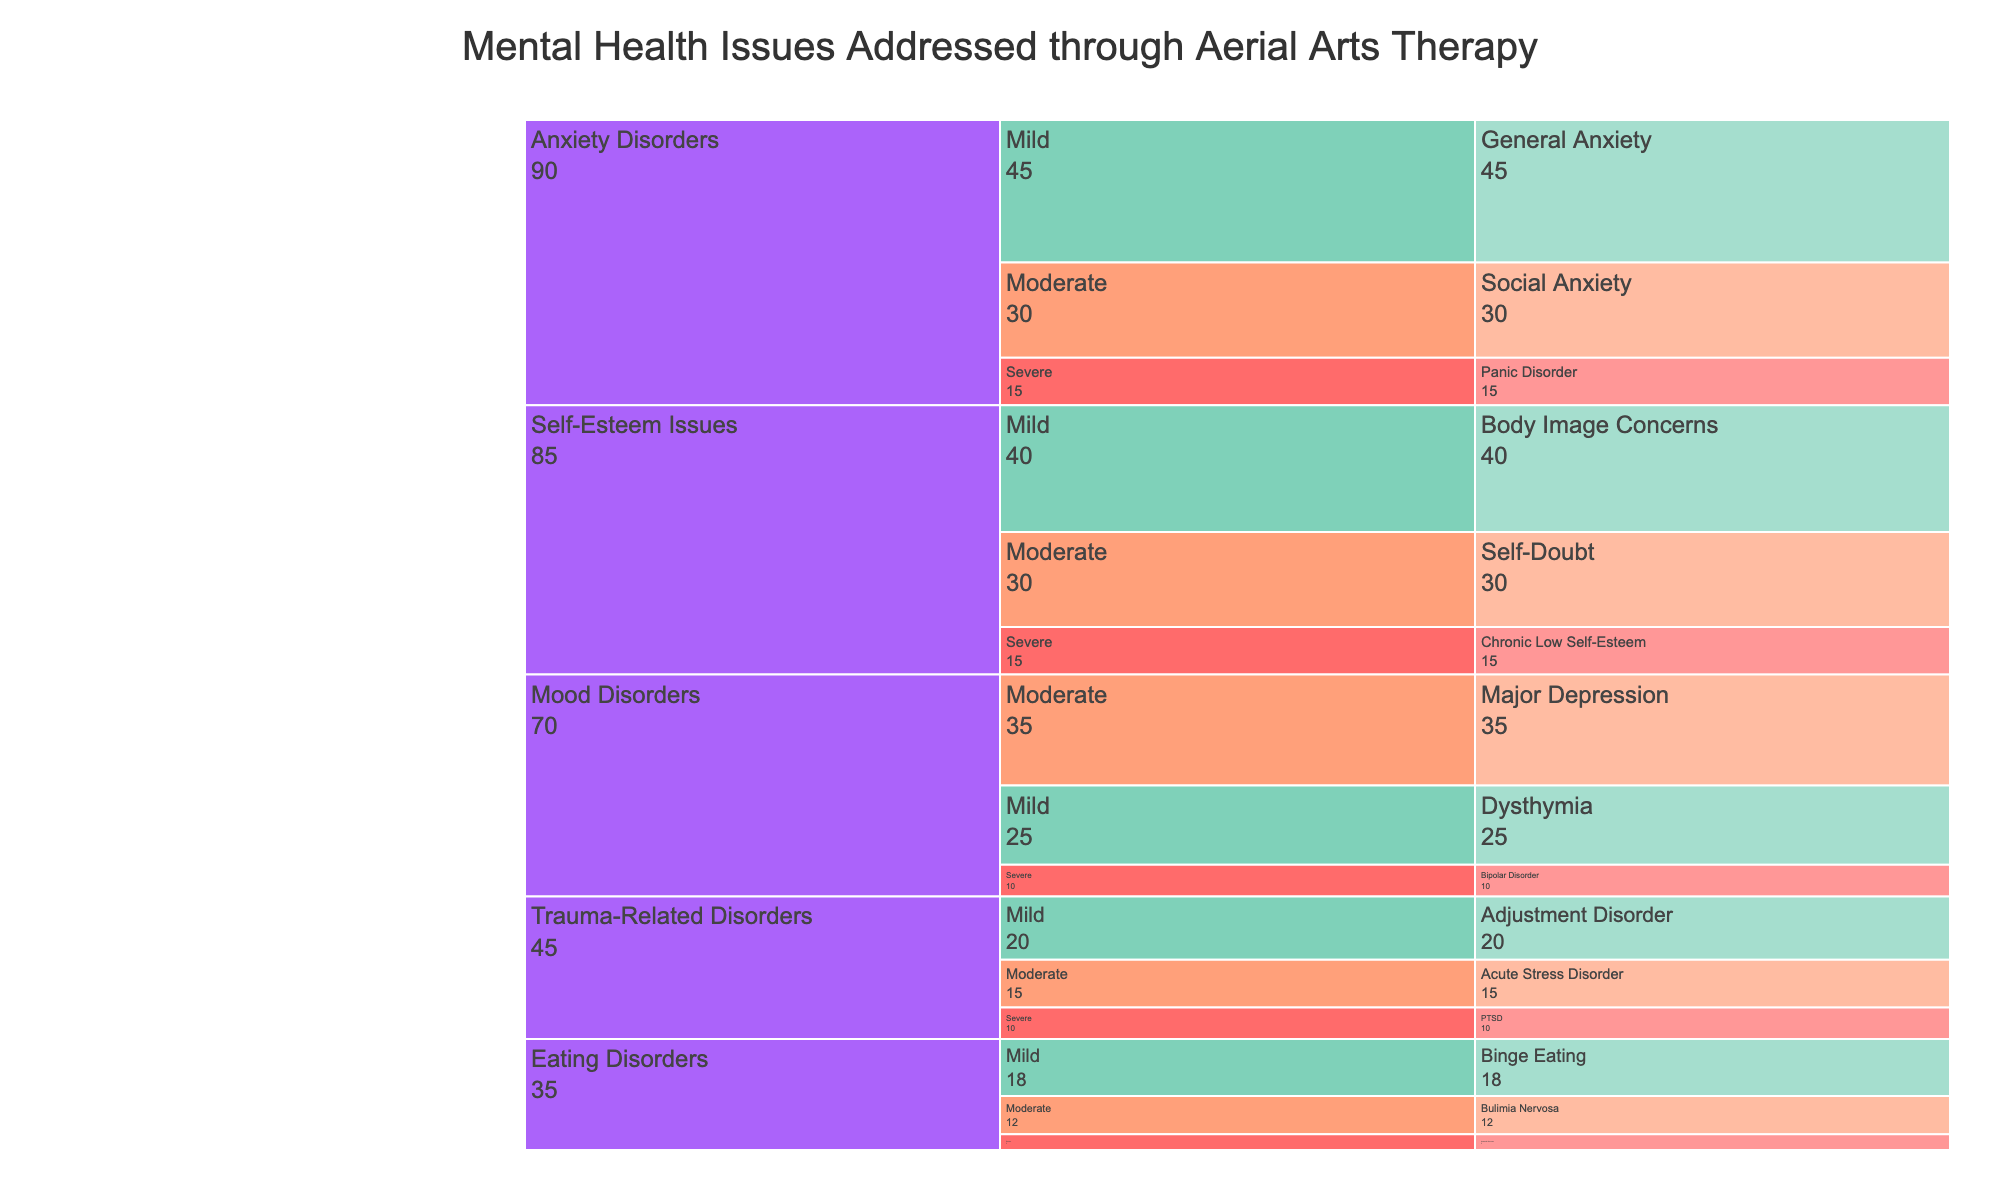What's the most common mental health issue addressed through aerial arts therapy? The chart shows "General Anxiety" under Anxiety Disorders (Mild severity) with a frequency of 45, which is the highest frequency among all issues.
Answer: General Anxiety Which severity level has the highest frequency in Mood Disorders? The chart shows Major Depression in the Moderate category with a frequency of 35, which is higher than the other severity levels in Mood Disorders.
Answer: Moderate What is the frequency of severe trauma-related disorders? The chart shows "PTSD" under Trauma-Related Disorders (Severe severity) with a frequency of 10.
Answer: 10 How does the frequency of mild anxiety disorders compare to severe anxiety disorders? The chart shows Mild anxiety disorders (General Anxiety) with a frequency of 45 and Severe anxiety disorders (Panic Disorder) with a frequency of 15. 45 is greater than 15, so mild anxiety disorders are more frequent than severe anxiety disorders.
Answer: Mild anxiety disorders are more frequent Which category has the lowest frequency for severe issues? The chart shows Severe eating disorders (Anorexia Nervosa) with a frequency of 5, which is the lowest among severe issues in other categories.
Answer: Eating Disorders What's the total frequency of all severe mental health issues combined? The frequencies of severe issues are Panic Disorder (15), Bipolar Disorder (10), PTSD (10), Anorexia Nervosa (5), and Chronic Low Self-Esteem (15). The total frequency is 15 + 10 + 10 + 5 + 15 = 55.
Answer: 55 Within anxiety disorders, which issue is addressed more frequently: mild or moderate severity? The chart shows General Anxiety (Mild) with a frequency of 45 and Social Anxiety (Moderate) with a frequency of 30. 45 is greater than 30, so mild severity is addressed more frequently.
Answer: Mild severity Which issue has the highest frequency among eating disorders? The chart shows "Binge Eating" under Eating Disorders (Mild severity) with a frequency of 18, which is the highest frequency among eating disorders.
Answer: Binge Eating What is the combined frequency of mild self-esteem issues and moderate self-esteem issues? The chart shows Body Image Concerns (Mild) with a frequency of 40 and Self-Doubt (Moderate) with a frequency of 30. The combined frequency is 40 + 30 = 70.
Answer: 70 How does the frequency of bipolar disorder compare to bulimia nervosa? The chart shows Bipolar Disorder (Severe) with a frequency of 10 and Bulimia Nervosa (Moderate) with a frequency of 12. 10 is less than 12, so bipolar disorder has a lower frequency than bulimia nervosa.
Answer: Lower frequency 